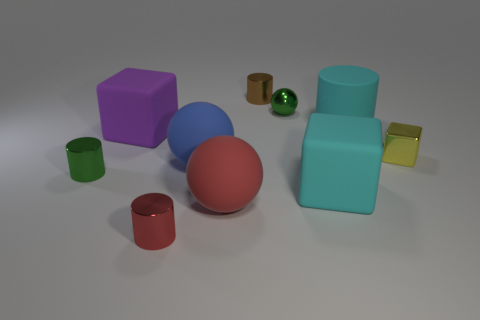There is a small object that is the same color as the tiny sphere; what material is it?
Give a very brief answer. Metal. Is there another big thing that has the same shape as the purple object?
Make the answer very short. Yes. Do the tiny green thing that is to the left of the big red ball and the cylinder that is in front of the big cyan cube have the same material?
Your answer should be compact. Yes. What size is the cyan object that is in front of the large cube on the left side of the cyan object that is in front of the metal block?
Provide a short and direct response. Large. There is a red thing that is the same size as the purple block; what is it made of?
Make the answer very short. Rubber. Is there a blue thing that has the same size as the red matte ball?
Offer a very short reply. Yes. Do the tiny yellow metal object and the blue object have the same shape?
Offer a terse response. No. Is there a small shiny cylinder behind the large ball that is in front of the large rubber block right of the red shiny cylinder?
Give a very brief answer. Yes. How many other objects are the same color as the metallic sphere?
Ensure brevity in your answer.  1. There is a cube right of the big cylinder; is it the same size as the shiny thing to the left of the red metallic cylinder?
Your answer should be very brief. Yes. 